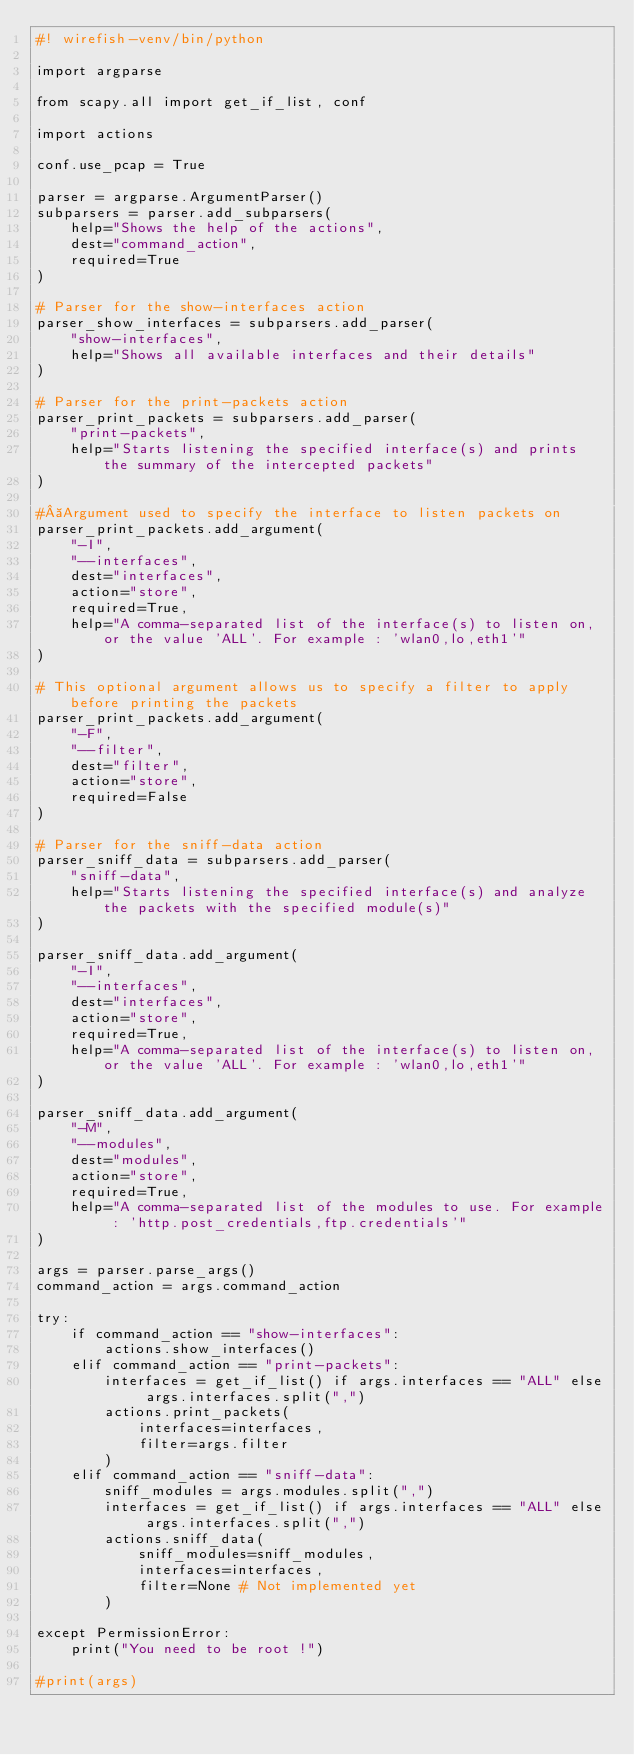<code> <loc_0><loc_0><loc_500><loc_500><_Python_>#! wirefish-venv/bin/python

import argparse

from scapy.all import get_if_list, conf

import actions

conf.use_pcap = True

parser = argparse.ArgumentParser()
subparsers = parser.add_subparsers(
    help="Shows the help of the actions",
    dest="command_action",
    required=True
)

# Parser for the show-interfaces action
parser_show_interfaces = subparsers.add_parser(
    "show-interfaces",
    help="Shows all available interfaces and their details"
)

# Parser for the print-packets action
parser_print_packets = subparsers.add_parser(
    "print-packets",
    help="Starts listening the specified interface(s) and prints the summary of the intercepted packets"
)

# Argument used to specify the interface to listen packets on
parser_print_packets.add_argument(
    "-I",
    "--interfaces",
    dest="interfaces",
    action="store",
    required=True,
    help="A comma-separated list of the interface(s) to listen on, or the value 'ALL'. For example : 'wlan0,lo,eth1'"
)

# This optional argument allows us to specify a filter to apply before printing the packets
parser_print_packets.add_argument(
    "-F",
    "--filter",
    dest="filter",
    action="store",
    required=False
)

# Parser for the sniff-data action
parser_sniff_data = subparsers.add_parser(
    "sniff-data",
    help="Starts listening the specified interface(s) and analyze the packets with the specified module(s)"
)

parser_sniff_data.add_argument(
    "-I",
    "--interfaces",
    dest="interfaces",
    action="store",
    required=True,
    help="A comma-separated list of the interface(s) to listen on, or the value 'ALL'. For example : 'wlan0,lo,eth1'"
)

parser_sniff_data.add_argument(
    "-M",
    "--modules",
    dest="modules",
    action="store",
    required=True,
    help="A comma-separated list of the modules to use. For example : 'http.post_credentials,ftp.credentials'"
)

args = parser.parse_args()
command_action = args.command_action

try:
    if command_action == "show-interfaces":
        actions.show_interfaces()
    elif command_action == "print-packets":
        interfaces = get_if_list() if args.interfaces == "ALL" else args.interfaces.split(",")
        actions.print_packets(
            interfaces=interfaces,
            filter=args.filter
        )
    elif command_action == "sniff-data":
        sniff_modules = args.modules.split(",")
        interfaces = get_if_list() if args.interfaces == "ALL" else args.interfaces.split(",")
        actions.sniff_data(
            sniff_modules=sniff_modules,
            interfaces=interfaces,
            filter=None # Not implemented yet
        )

except PermissionError:
    print("You need to be root !")

#print(args)
</code> 